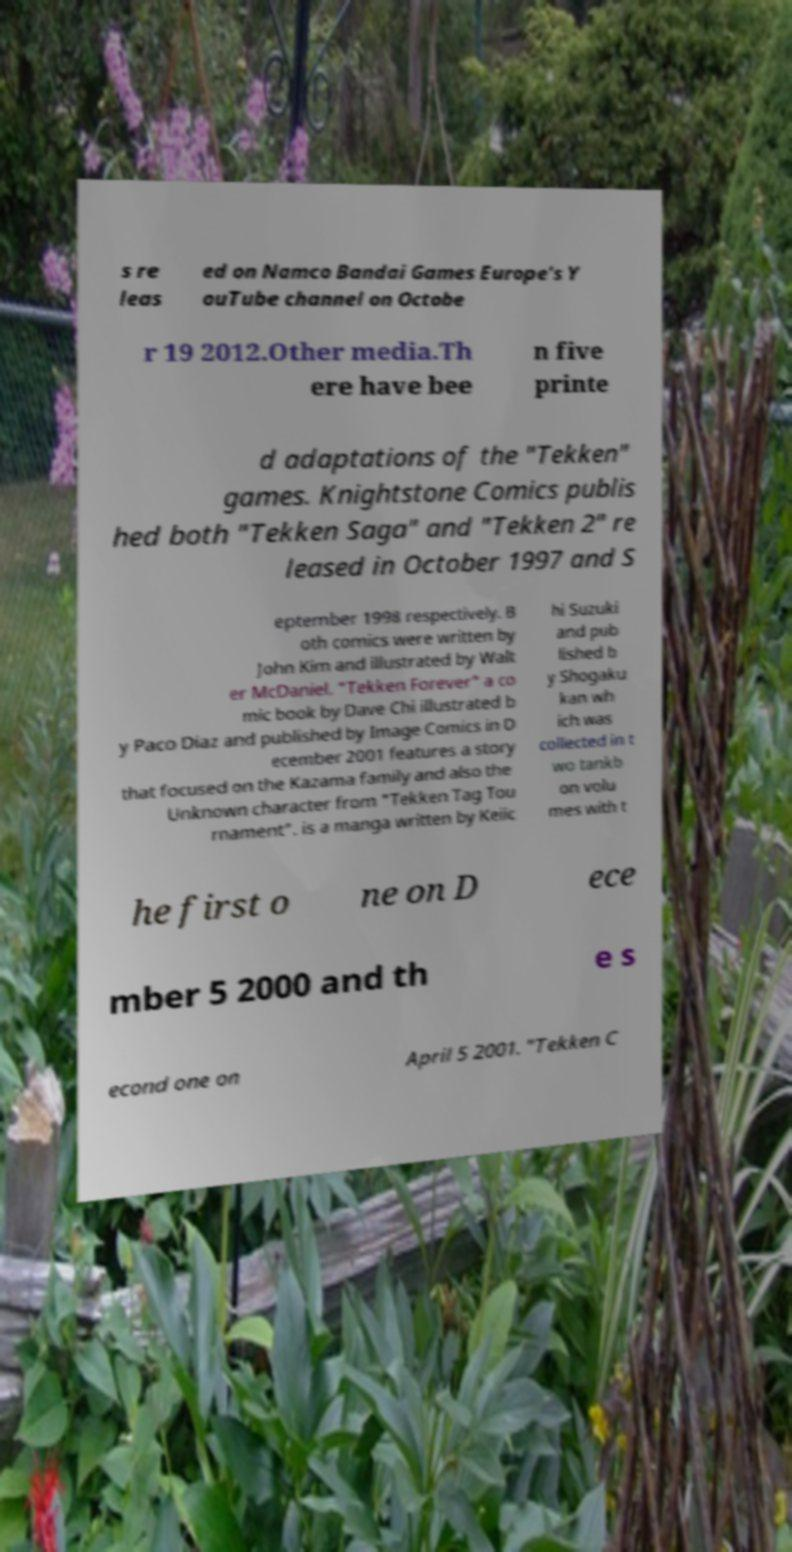For documentation purposes, I need the text within this image transcribed. Could you provide that? s re leas ed on Namco Bandai Games Europe's Y ouTube channel on Octobe r 19 2012.Other media.Th ere have bee n five printe d adaptations of the "Tekken" games. Knightstone Comics publis hed both "Tekken Saga" and "Tekken 2" re leased in October 1997 and S eptember 1998 respectively. B oth comics were written by John Kim and illustrated by Walt er McDaniel. "Tekken Forever" a co mic book by Dave Chi illustrated b y Paco Diaz and published by Image Comics in D ecember 2001 features a story that focused on the Kazama family and also the Unknown character from "Tekken Tag Tou rnament". is a manga written by Keiic hi Suzuki and pub lished b y Shogaku kan wh ich was collected in t wo tankb on volu mes with t he first o ne on D ece mber 5 2000 and th e s econd one on April 5 2001. "Tekken C 